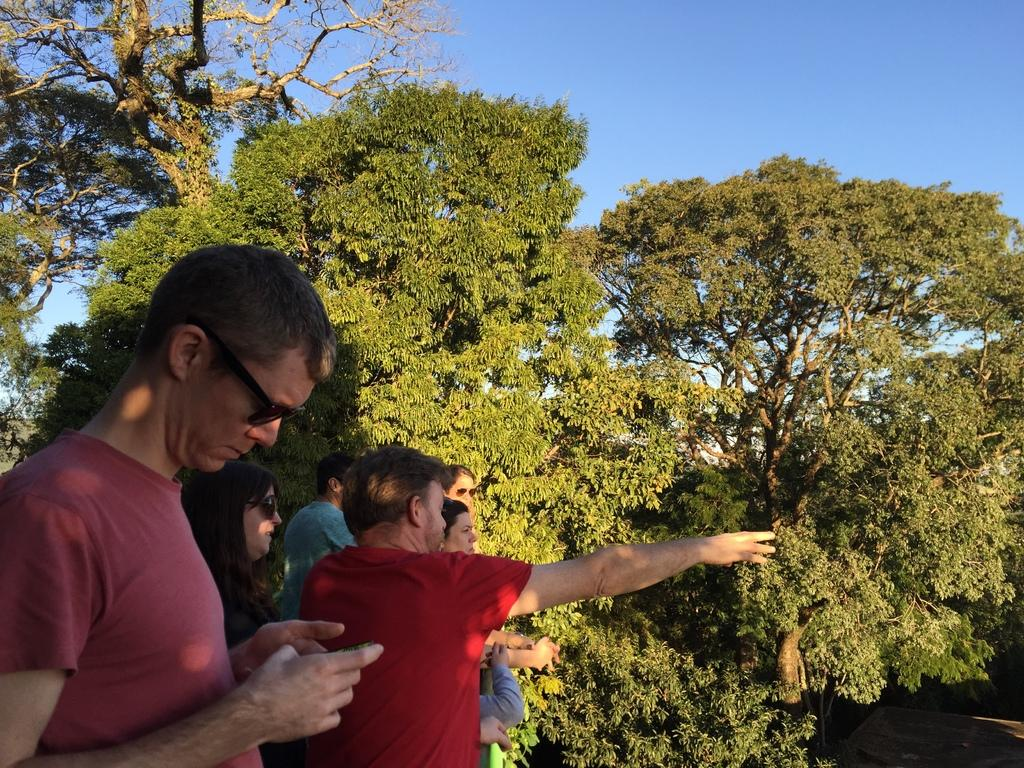What can be seen on the left side of the image? There are people standing on the left side of the image. What type of natural elements are visible in the background of the image? There are trees in the background of the image. What is visible in the sky in the background of the image? The sky is visible in the background of the image. What type of knot is being tied by the people on the left side of the image? There is no knot-tying activity depicted in the image; the people are simply standing. What kind of toys can be seen in the image? There are no toys present in the image. 